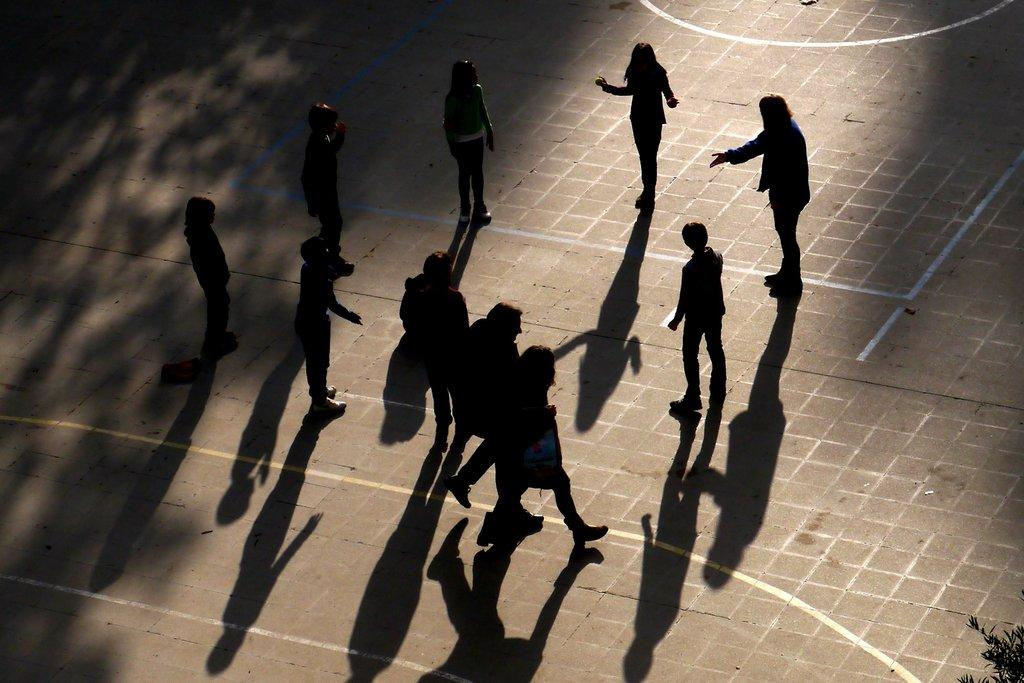What is the main subject of the image? The main subject of the image is a group of people. Where are the people located in the image? The people are standing on the ground. What can be seen in the bottom right corner of the image? There are leaves on a tree branch at the bottom right of the image. What type of cent is visible on the wire in the image? There is no cent or wire present in the image. How many skateboards are being used by the group of people in the image? There is no indication of skateboards or their use in the image. 